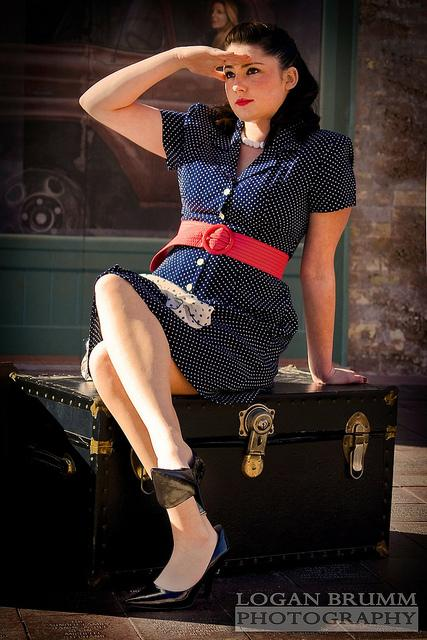What is usually held in the item being sat on here? clothing 